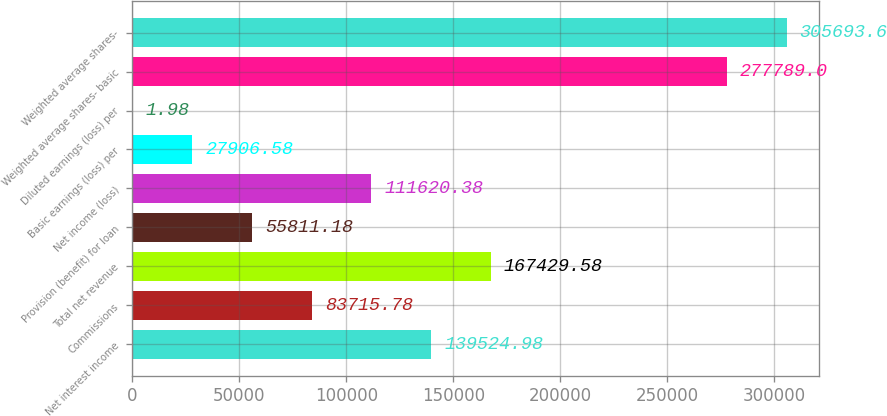Convert chart. <chart><loc_0><loc_0><loc_500><loc_500><bar_chart><fcel>Net interest income<fcel>Commissions<fcel>Total net revenue<fcel>Provision (benefit) for loan<fcel>Net income (loss)<fcel>Basic earnings (loss) per<fcel>Diluted earnings (loss) per<fcel>Weighted average shares- basic<fcel>Weighted average shares-<nl><fcel>139525<fcel>83715.8<fcel>167430<fcel>55811.2<fcel>111620<fcel>27906.6<fcel>1.98<fcel>277789<fcel>305694<nl></chart> 